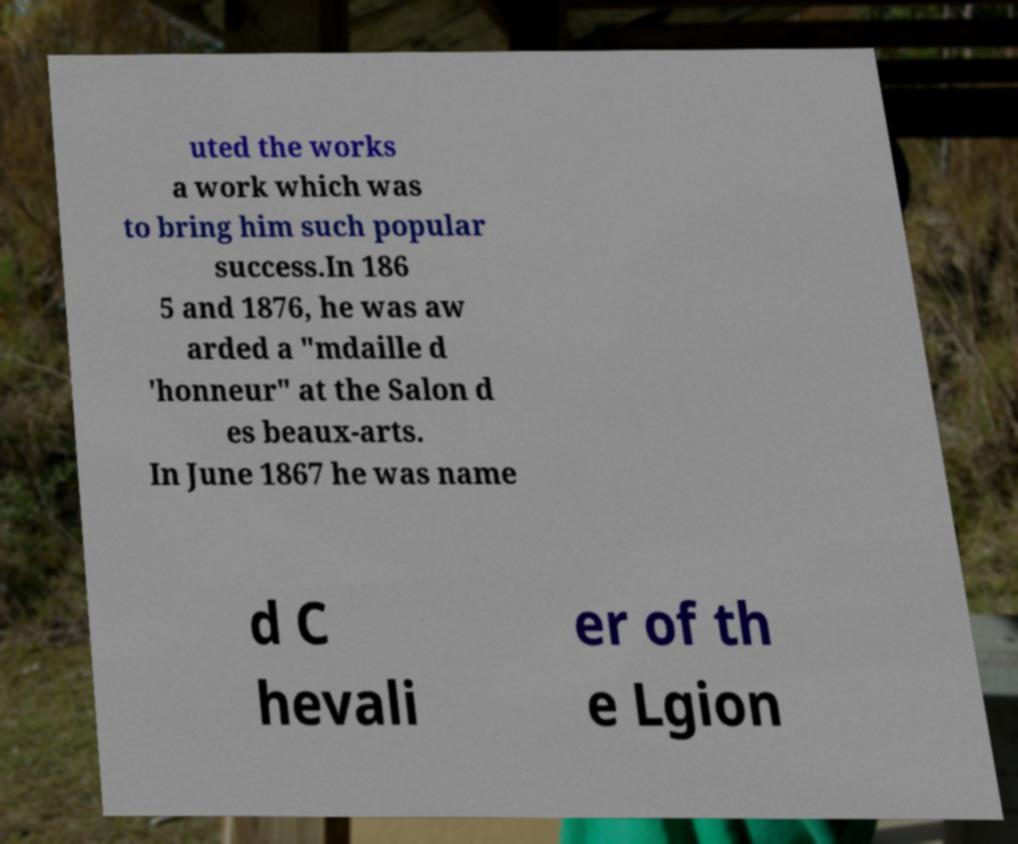Could you extract and type out the text from this image? uted the works a work which was to bring him such popular success.In 186 5 and 1876, he was aw arded a "mdaille d 'honneur" at the Salon d es beaux-arts. In June 1867 he was name d C hevali er of th e Lgion 